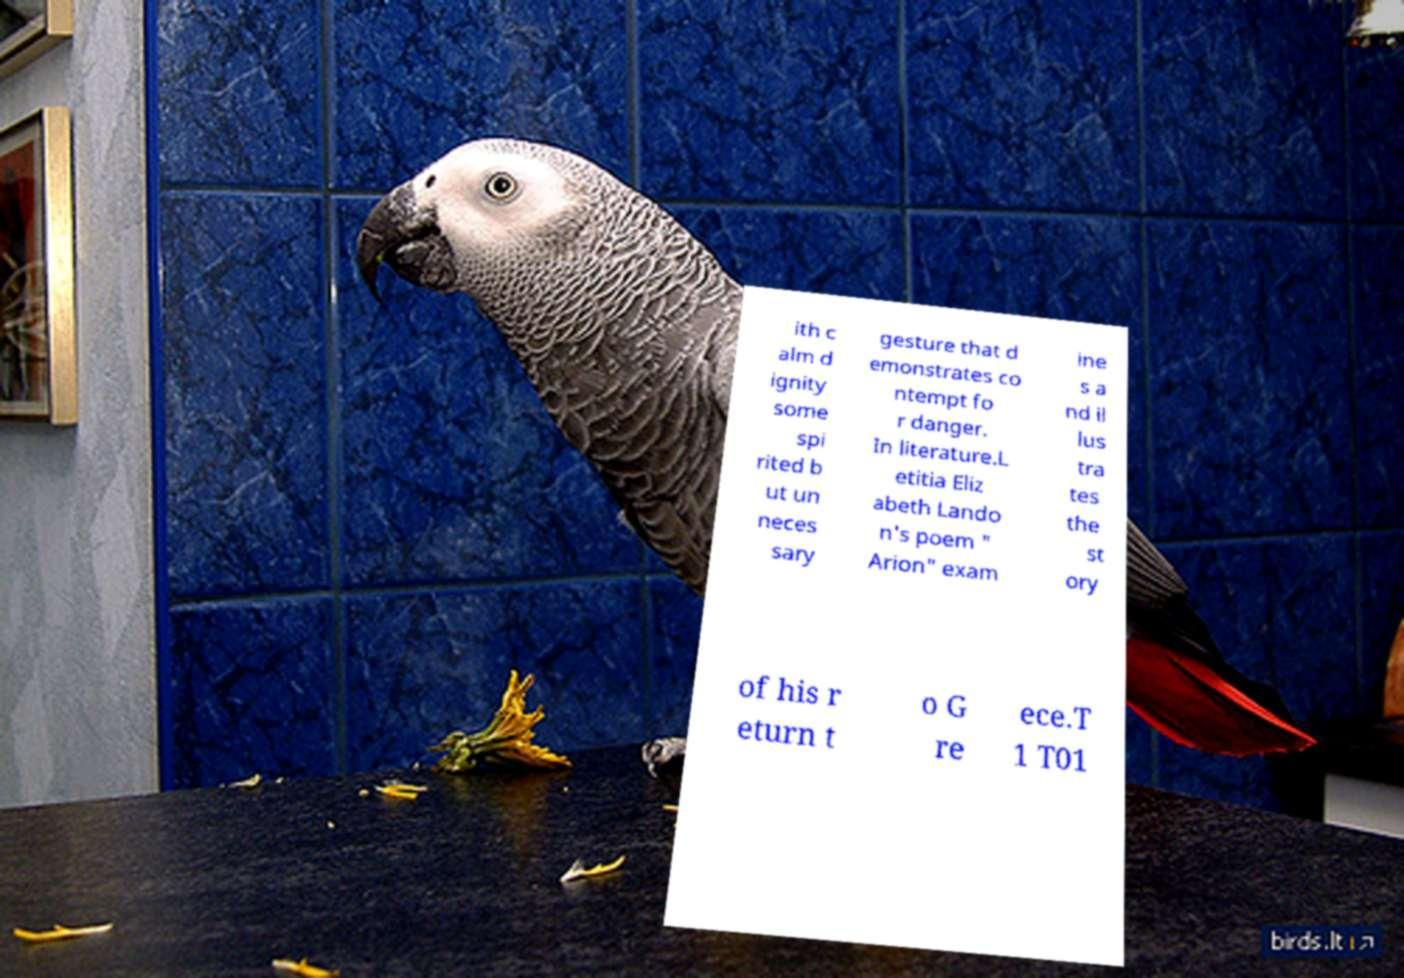Could you extract and type out the text from this image? ith c alm d ignity some spi rited b ut un neces sary gesture that d emonstrates co ntempt fo r danger. In literature.L etitia Eliz abeth Lando n's poem " Arion" exam ine s a nd il lus tra tes the st ory of his r eturn t o G re ece.T 1 T01 